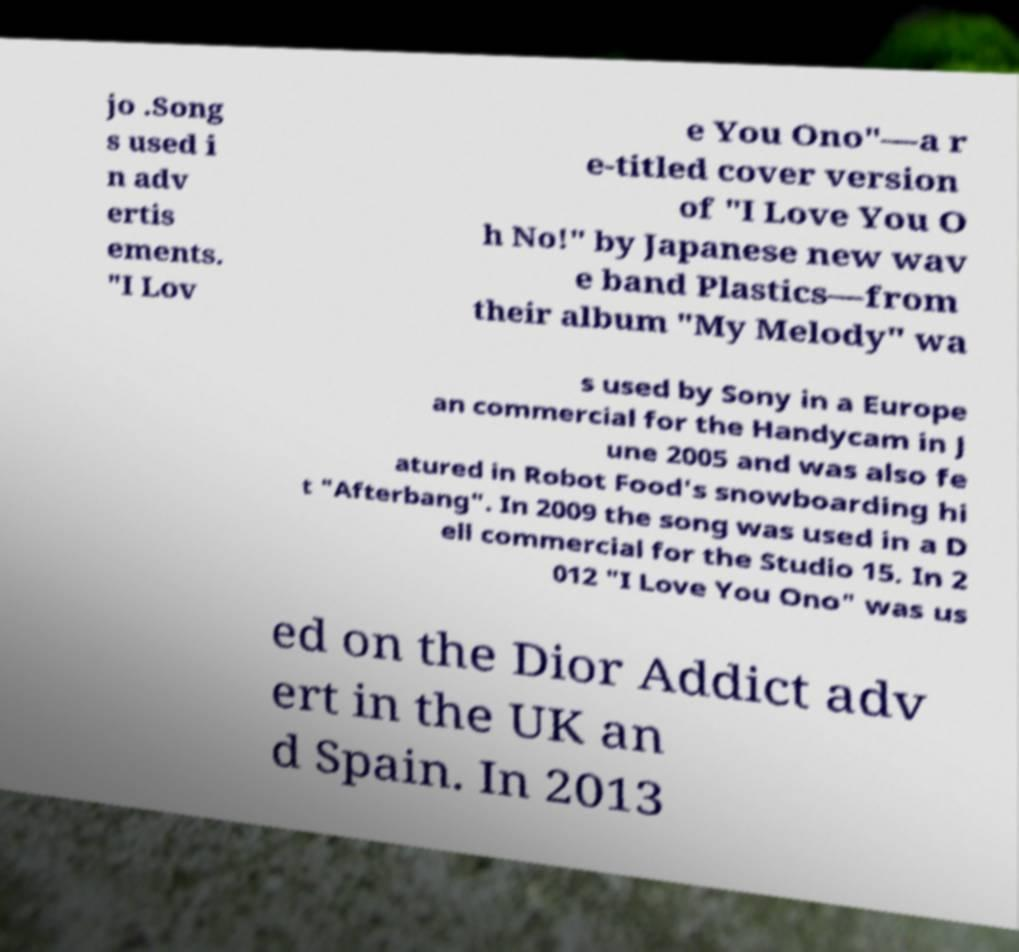I need the written content from this picture converted into text. Can you do that? jo .Song s used i n adv ertis ements. "I Lov e You Ono"—a r e-titled cover version of "I Love You O h No!" by Japanese new wav e band Plastics—from their album "My Melody" wa s used by Sony in a Europe an commercial for the Handycam in J une 2005 and was also fe atured in Robot Food's snowboarding hi t "Afterbang". In 2009 the song was used in a D ell commercial for the Studio 15. In 2 012 "I Love You Ono" was us ed on the Dior Addict adv ert in the UK an d Spain. In 2013 